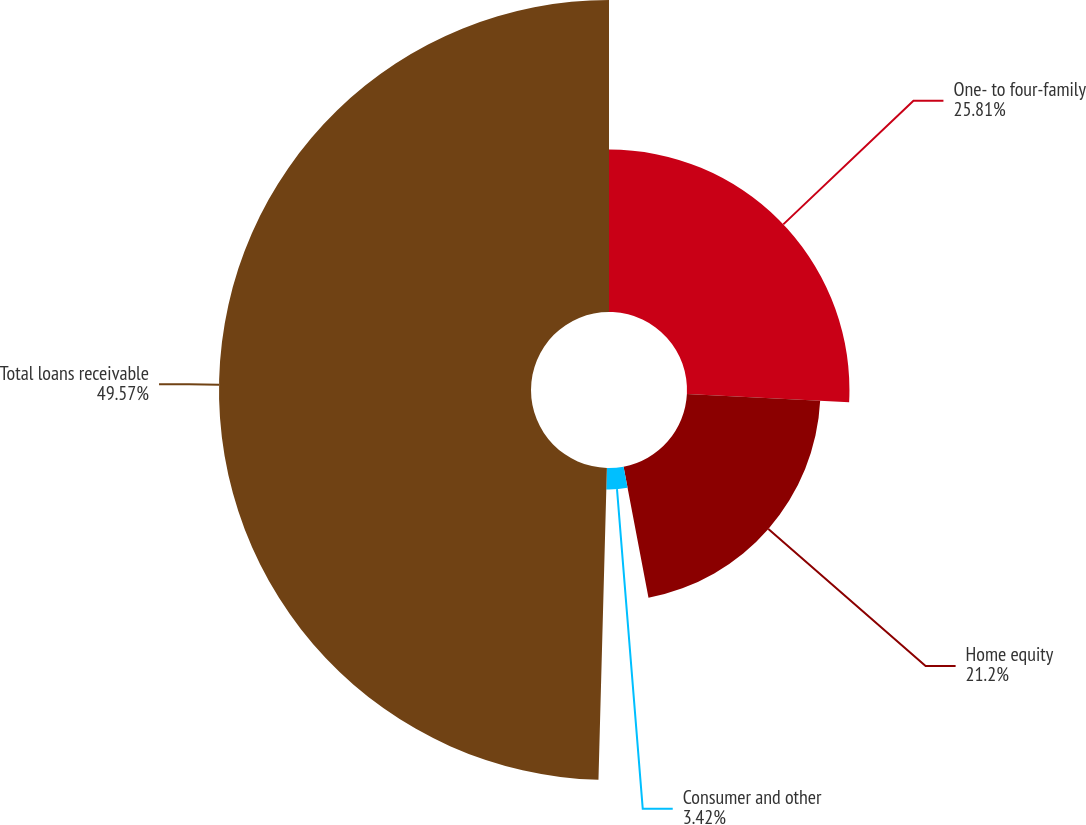Convert chart to OTSL. <chart><loc_0><loc_0><loc_500><loc_500><pie_chart><fcel>One- to four-family<fcel>Home equity<fcel>Consumer and other<fcel>Total loans receivable<nl><fcel>25.81%<fcel>21.2%<fcel>3.42%<fcel>49.57%<nl></chart> 